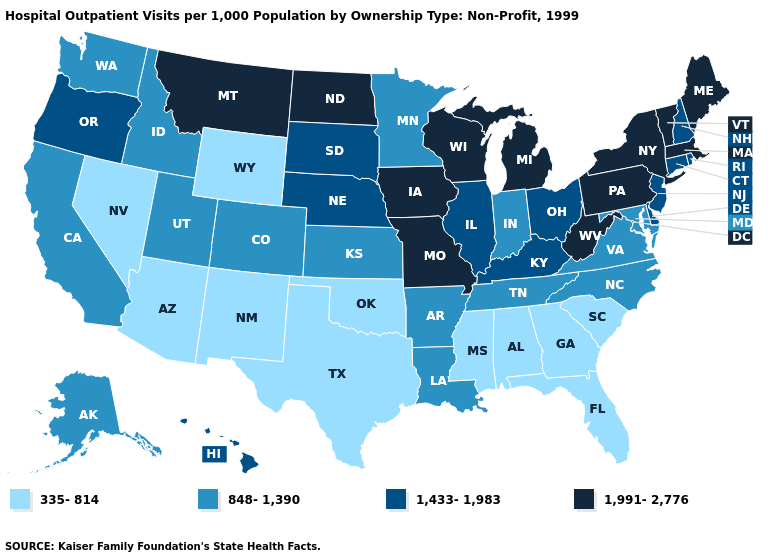What is the highest value in the USA?
Write a very short answer. 1,991-2,776. Which states hav the highest value in the West?
Give a very brief answer. Montana. What is the value of Colorado?
Quick response, please. 848-1,390. Name the states that have a value in the range 1,433-1,983?
Quick response, please. Connecticut, Delaware, Hawaii, Illinois, Kentucky, Nebraska, New Hampshire, New Jersey, Ohio, Oregon, Rhode Island, South Dakota. Among the states that border South Carolina , which have the lowest value?
Keep it brief. Georgia. What is the highest value in the USA?
Write a very short answer. 1,991-2,776. What is the value of New Hampshire?
Quick response, please. 1,433-1,983. Name the states that have a value in the range 335-814?
Be succinct. Alabama, Arizona, Florida, Georgia, Mississippi, Nevada, New Mexico, Oklahoma, South Carolina, Texas, Wyoming. Does the first symbol in the legend represent the smallest category?
Give a very brief answer. Yes. Which states have the lowest value in the Northeast?
Write a very short answer. Connecticut, New Hampshire, New Jersey, Rhode Island. Name the states that have a value in the range 848-1,390?
Quick response, please. Alaska, Arkansas, California, Colorado, Idaho, Indiana, Kansas, Louisiana, Maryland, Minnesota, North Carolina, Tennessee, Utah, Virginia, Washington. Which states have the highest value in the USA?
Give a very brief answer. Iowa, Maine, Massachusetts, Michigan, Missouri, Montana, New York, North Dakota, Pennsylvania, Vermont, West Virginia, Wisconsin. What is the value of Missouri?
Write a very short answer. 1,991-2,776. Does California have a higher value than Maryland?
Give a very brief answer. No. Does the map have missing data?
Be succinct. No. 